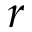<formula> <loc_0><loc_0><loc_500><loc_500>r</formula> 